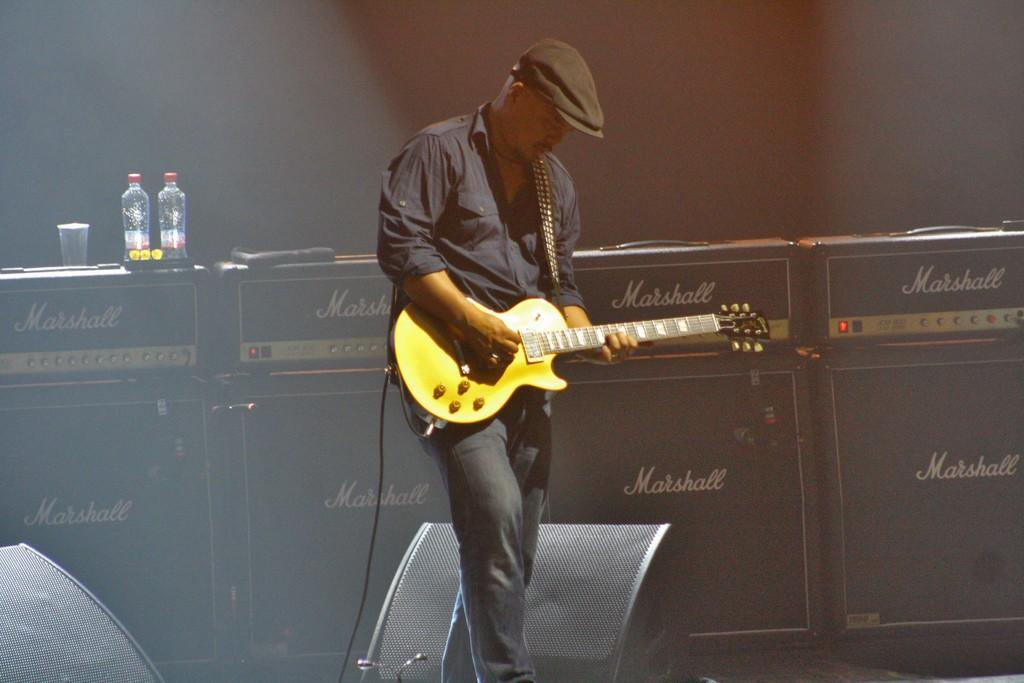What is the main subject of the image? There is a person in the image. What is the person wearing? The person is wearing a black dress. What is the person holding? The person is holding a guitar. What can be seen in the background of the image? There is a desk in the background of the image. Can you describe the items on the desk? Unfortunately, the transcript does not specify what the items on the desk are. How much income does the person earn from playing the guitar in the image? There is no information about the person's income or their guitar-playing abilities in the image. Is there a ball visible in the image? No, there is no ball present in the image. 